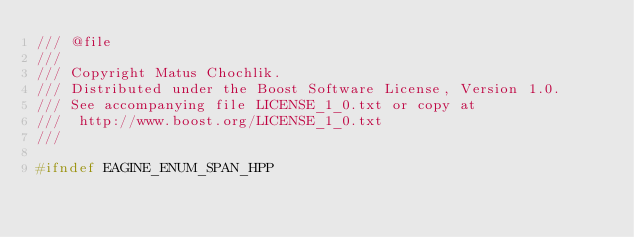<code> <loc_0><loc_0><loc_500><loc_500><_C++_>/// @file
///
/// Copyright Matus Chochlik.
/// Distributed under the Boost Software License, Version 1.0.
/// See accompanying file LICENSE_1_0.txt or copy at
///  http://www.boost.org/LICENSE_1_0.txt
///

#ifndef EAGINE_ENUM_SPAN_HPP</code> 